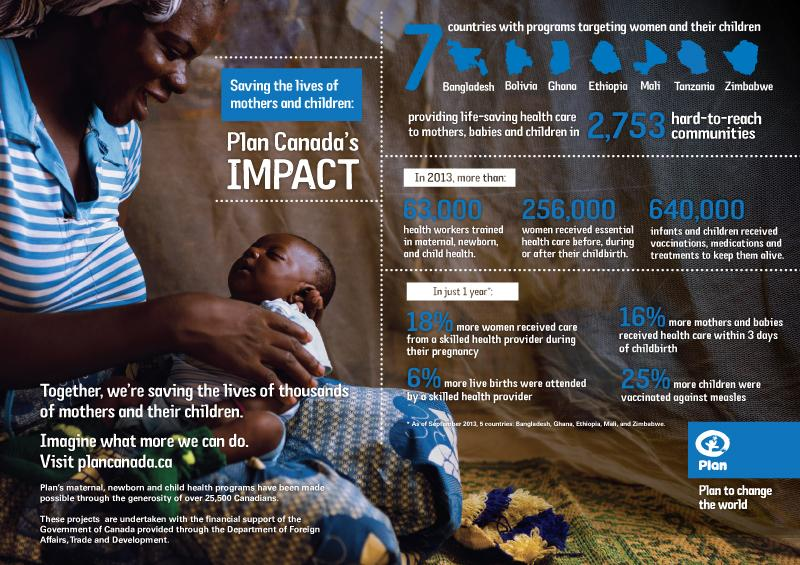Highlight a few significant elements in this photo. In 2013, a total of 640,000 infants and children received vaccinations, medications, and treatments to help them survive. The infographic lists India, USA, and Tanzania. The speaker indicates that Tanzania is the correct answer. The increase in percentage of children who received measles vaccination was 25%. In 2013, an estimated 256,000 women received essential health care services before, during, or after childbirth. 